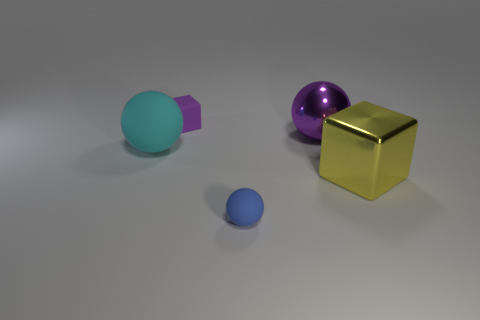The object that is made of the same material as the big purple ball is what color?
Offer a terse response. Yellow. How many tiny red balls have the same material as the blue ball?
Make the answer very short. 0. There is a big cyan object; how many large cyan things are to the right of it?
Your response must be concise. 0. Are the object on the right side of the large purple metal thing and the sphere that is behind the cyan matte thing made of the same material?
Provide a short and direct response. Yes. Are there more small purple objects in front of the yellow shiny object than blue matte things left of the big purple metallic ball?
Provide a succinct answer. No. There is a sphere that is the same color as the small block; what is its material?
Provide a short and direct response. Metal. Are there any other things that have the same shape as the blue object?
Your answer should be compact. Yes. What is the thing that is right of the blue ball and behind the cyan ball made of?
Give a very brief answer. Metal. Are the cyan sphere and the purple thing that is to the left of the small rubber ball made of the same material?
Your answer should be compact. Yes. How many things are either yellow metal things or big spheres that are on the right side of the blue rubber sphere?
Your response must be concise. 2. 